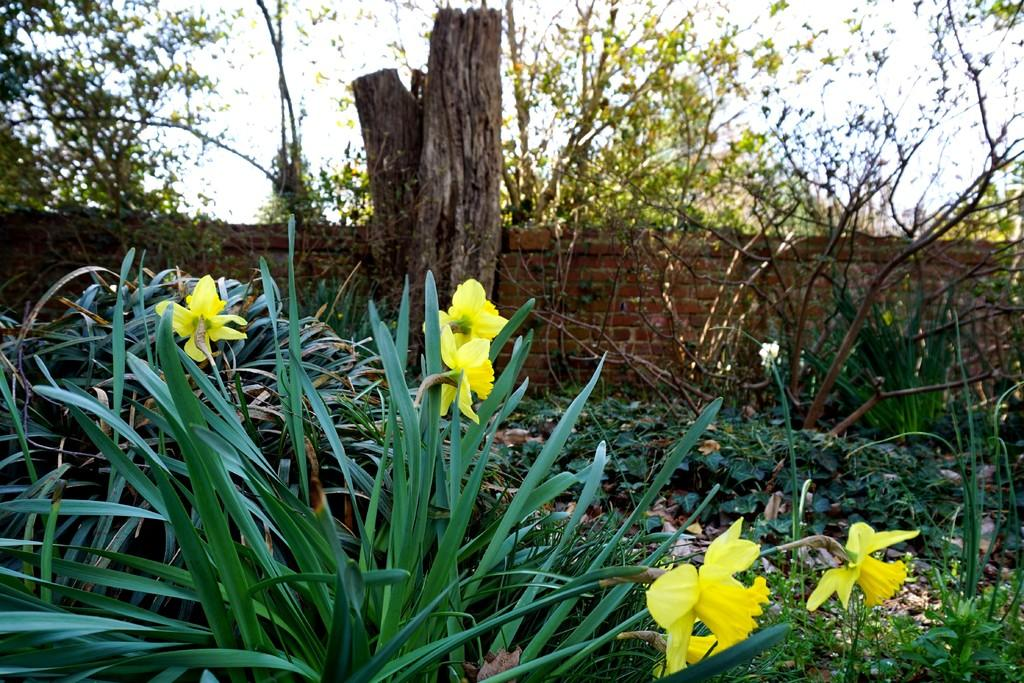What type of vegetation can be seen in the image? There are plants and trees in the image. Can you describe the location of the plants and trees in the image? The plants and trees are in front of a wall in the image. How many times has the calculator been used in the image? There is no calculator present in the image. Can you describe the dirt on the plants in the image? There is no dirt visible on the plants in the image. 